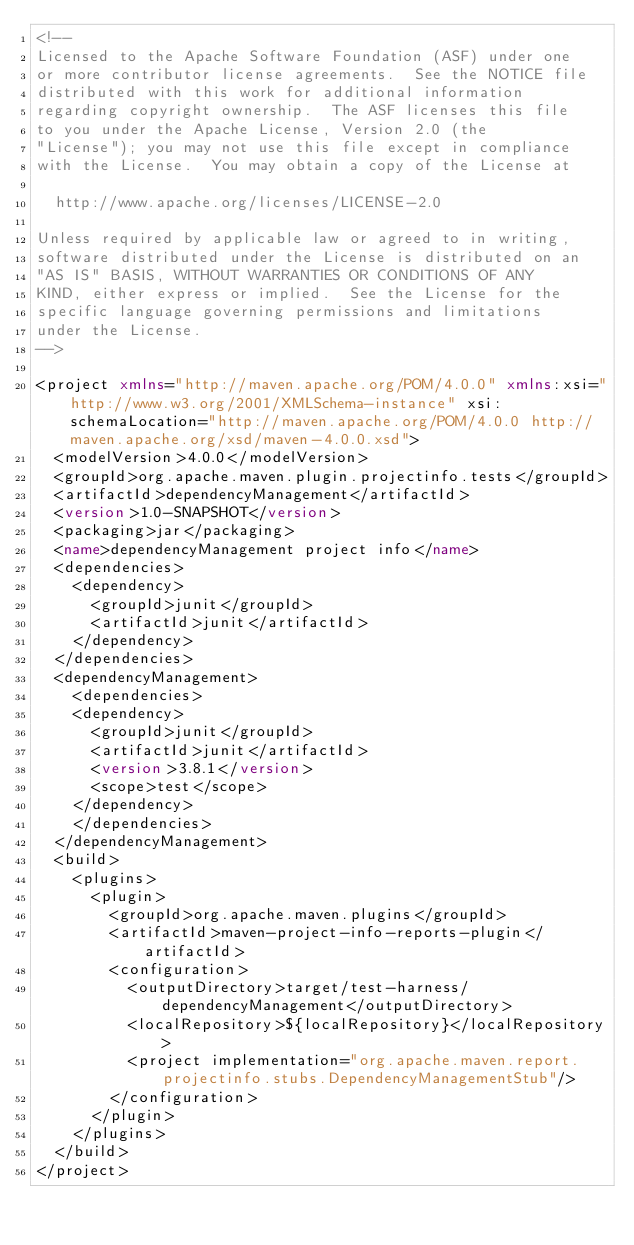<code> <loc_0><loc_0><loc_500><loc_500><_XML_><!--
Licensed to the Apache Software Foundation (ASF) under one
or more contributor license agreements.  See the NOTICE file
distributed with this work for additional information
regarding copyright ownership.  The ASF licenses this file
to you under the Apache License, Version 2.0 (the
"License"); you may not use this file except in compliance
with the License.  You may obtain a copy of the License at

  http://www.apache.org/licenses/LICENSE-2.0

Unless required by applicable law or agreed to in writing,
software distributed under the License is distributed on an
"AS IS" BASIS, WITHOUT WARRANTIES OR CONDITIONS OF ANY
KIND, either express or implied.  See the License for the
specific language governing permissions and limitations
under the License.
-->

<project xmlns="http://maven.apache.org/POM/4.0.0" xmlns:xsi="http://www.w3.org/2001/XMLSchema-instance" xsi:schemaLocation="http://maven.apache.org/POM/4.0.0 http://maven.apache.org/xsd/maven-4.0.0.xsd">
  <modelVersion>4.0.0</modelVersion>
  <groupId>org.apache.maven.plugin.projectinfo.tests</groupId>
  <artifactId>dependencyManagement</artifactId>
  <version>1.0-SNAPSHOT</version>
  <packaging>jar</packaging>
  <name>dependencyManagement project info</name>
  <dependencies>
    <dependency>
      <groupId>junit</groupId>
      <artifactId>junit</artifactId>
    </dependency>
  </dependencies>
  <dependencyManagement>
    <dependencies>
    <dependency>
      <groupId>junit</groupId>
      <artifactId>junit</artifactId>
      <version>3.8.1</version>
      <scope>test</scope>
    </dependency>
    </dependencies>
  </dependencyManagement>
  <build>
    <plugins>
      <plugin>
        <groupId>org.apache.maven.plugins</groupId>
        <artifactId>maven-project-info-reports-plugin</artifactId>
        <configuration>
          <outputDirectory>target/test-harness/dependencyManagement</outputDirectory>
          <localRepository>${localRepository}</localRepository>
          <project implementation="org.apache.maven.report.projectinfo.stubs.DependencyManagementStub"/>
        </configuration>
      </plugin>
    </plugins>
  </build>
</project>
</code> 